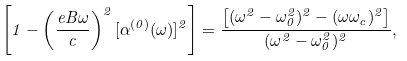Convert formula to latex. <formula><loc_0><loc_0><loc_500><loc_500>\left [ 1 - \left ( \frac { e B \omega } { c } \right ) ^ { 2 } [ \alpha ^ { ( 0 ) } ( \omega ) ] ^ { 2 } \right ] = \frac { \left [ ( \omega ^ { 2 } - \omega _ { 0 } ^ { 2 } ) ^ { 2 } - ( \omega \omega _ { c } ) ^ { 2 } \right ] } { ( \omega ^ { 2 } - \omega _ { 0 } ^ { 2 } ) ^ { 2 } } ,</formula> 